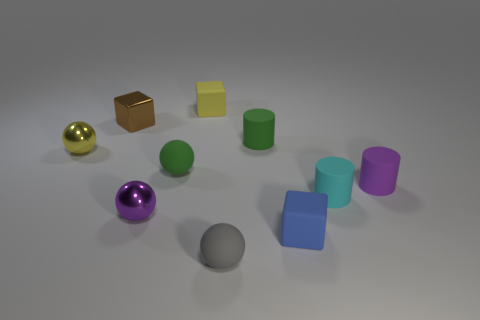Subtract all small brown cubes. How many cubes are left? 2 Subtract all cubes. How many objects are left? 7 Subtract all yellow cylinders. Subtract all brown blocks. How many cylinders are left? 3 Subtract all cyan blocks. How many red cylinders are left? 0 Subtract all blocks. Subtract all big red rubber blocks. How many objects are left? 7 Add 7 tiny green matte things. How many tiny green matte things are left? 9 Add 4 tiny blue objects. How many tiny blue objects exist? 5 Subtract all blue cubes. How many cubes are left? 2 Subtract 1 yellow blocks. How many objects are left? 9 